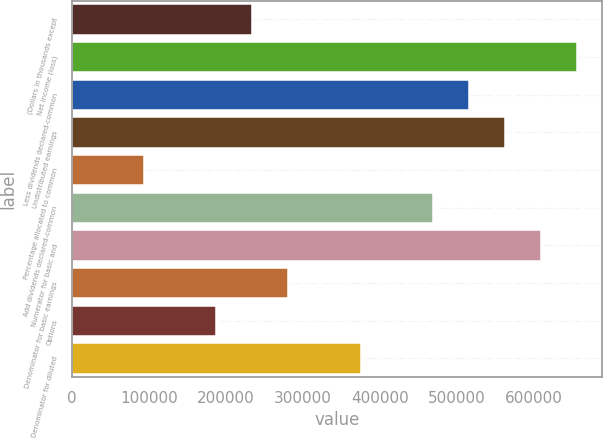<chart> <loc_0><loc_0><loc_500><loc_500><bar_chart><fcel>(Dollars in thousands except<fcel>Net income (loss)<fcel>Less dividends declared-common<fcel>Undistributed earnings<fcel>Percentage allocated to common<fcel>Add dividends declared-common<fcel>Numerator for basic and<fcel>Denominator for basic earnings<fcel>Options<fcel>Denominator for diluted<nl><fcel>234490<fcel>656551<fcel>515864<fcel>562759<fcel>93802.7<fcel>468968<fcel>609655<fcel>281385<fcel>187594<fcel>375177<nl></chart> 